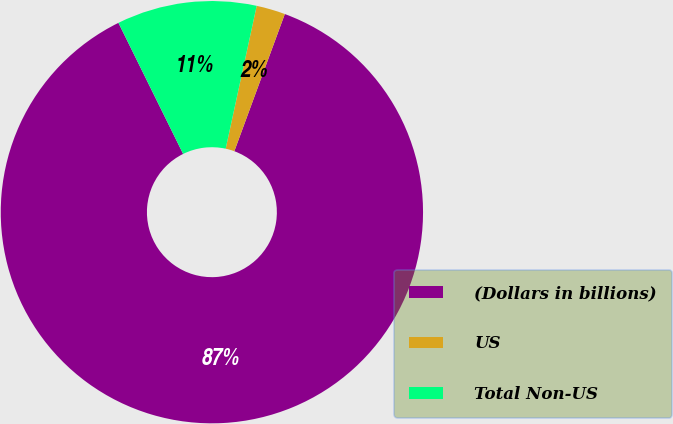Convert chart to OTSL. <chart><loc_0><loc_0><loc_500><loc_500><pie_chart><fcel>(Dollars in billions)<fcel>US<fcel>Total Non-US<nl><fcel>87.09%<fcel>2.21%<fcel>10.7%<nl></chart> 